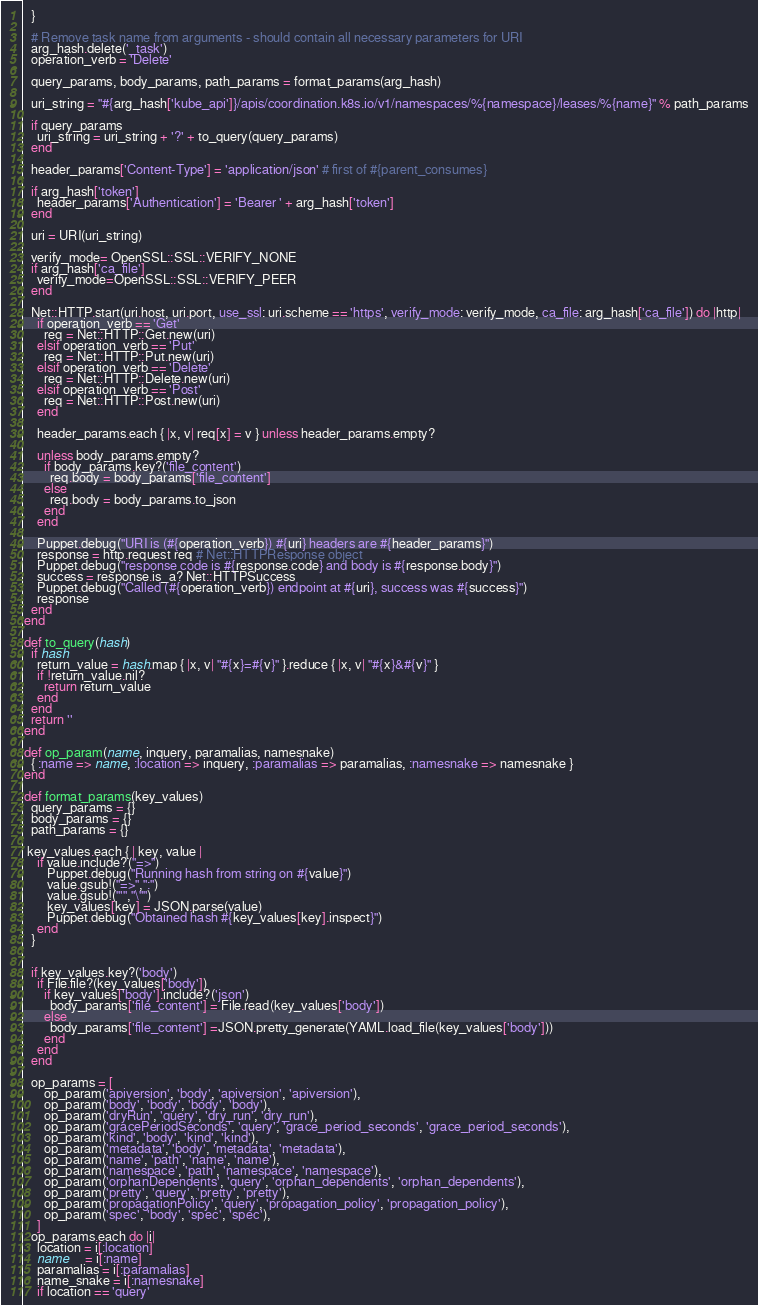<code> <loc_0><loc_0><loc_500><loc_500><_Ruby_>  }

  # Remove task name from arguments - should contain all necessary parameters for URI
  arg_hash.delete('_task')
  operation_verb = 'Delete'

  query_params, body_params, path_params = format_params(arg_hash)

  uri_string = "#{arg_hash['kube_api']}/apis/coordination.k8s.io/v1/namespaces/%{namespace}/leases/%{name}" % path_params

  if query_params
    uri_string = uri_string + '?' + to_query(query_params)
  end

  header_params['Content-Type'] = 'application/json' # first of #{parent_consumes}

  if arg_hash['token']
    header_params['Authentication'] = 'Bearer ' + arg_hash['token']
  end

  uri = URI(uri_string)
 
  verify_mode= OpenSSL::SSL::VERIFY_NONE
  if arg_hash['ca_file']
    verify_mode=OpenSSL::SSL::VERIFY_PEER
  end

  Net::HTTP.start(uri.host, uri.port, use_ssl: uri.scheme == 'https', verify_mode: verify_mode, ca_file: arg_hash['ca_file']) do |http|
    if operation_verb == 'Get'
      req = Net::HTTP::Get.new(uri)
    elsif operation_verb == 'Put'
      req = Net::HTTP::Put.new(uri)
    elsif operation_verb == 'Delete'
      req = Net::HTTP::Delete.new(uri)
    elsif operation_verb == 'Post'
      req = Net::HTTP::Post.new(uri)
    end

    header_params.each { |x, v| req[x] = v } unless header_params.empty?

    unless body_params.empty?
      if body_params.key?('file_content')
        req.body = body_params['file_content']
      else
        req.body = body_params.to_json
      end
    end

    Puppet.debug("URI is (#{operation_verb}) #{uri} headers are #{header_params}")
    response = http.request req # Net::HTTPResponse object
    Puppet.debug("response code is #{response.code} and body is #{response.body}")
    success = response.is_a? Net::HTTPSuccess
    Puppet.debug("Called (#{operation_verb}) endpoint at #{uri}, success was #{success}")
    response
  end
end

def to_query(hash)
  if hash
    return_value = hash.map { |x, v| "#{x}=#{v}" }.reduce { |x, v| "#{x}&#{v}" }
    if !return_value.nil?
      return return_value
    end
  end
  return ''
end

def op_param(name, inquery, paramalias, namesnake)
  { :name => name, :location => inquery, :paramalias => paramalias, :namesnake => namesnake }
end

def format_params(key_values)
  query_params = {}
  body_params = {}
  path_params = {}

 key_values.each { | key, value |
    if value.include?("=>")
       Puppet.debug("Running hash from string on #{value}")
       value.gsub!("=>",":")
       value.gsub!("'","\"")
       key_values[key] = JSON.parse(value)
       Puppet.debug("Obtained hash #{key_values[key].inspect}")
    end
  }


  if key_values.key?('body')
    if File.file?(key_values['body'])
      if key_values['body'].include?('json')
        body_params['file_content'] = File.read(key_values['body'])
      else
        body_params['file_content'] =JSON.pretty_generate(YAML.load_file(key_values['body']))
      end
    end
  end

  op_params = [
      op_param('apiversion', 'body', 'apiversion', 'apiversion'),
      op_param('body', 'body', 'body', 'body'),
      op_param('dryRun', 'query', 'dry_run', 'dry_run'),
      op_param('gracePeriodSeconds', 'query', 'grace_period_seconds', 'grace_period_seconds'),
      op_param('kind', 'body', 'kind', 'kind'),
      op_param('metadata', 'body', 'metadata', 'metadata'),
      op_param('name', 'path', 'name', 'name'),
      op_param('namespace', 'path', 'namespace', 'namespace'),
      op_param('orphanDependents', 'query', 'orphan_dependents', 'orphan_dependents'),
      op_param('pretty', 'query', 'pretty', 'pretty'),
      op_param('propagationPolicy', 'query', 'propagation_policy', 'propagation_policy'),
      op_param('spec', 'body', 'spec', 'spec'),
    ]
  op_params.each do |i|
    location = i[:location]
    name     = i[:name]
    paramalias = i[:paramalias]
    name_snake = i[:namesnake]
    if location == 'query'</code> 